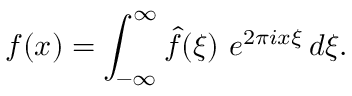Convert formula to latex. <formula><loc_0><loc_0><loc_500><loc_500>f ( x ) = \int _ { - \infty } ^ { \infty } { \widehat { f } } ( \xi ) \ e ^ { 2 \pi i x \xi } \, d \xi .</formula> 